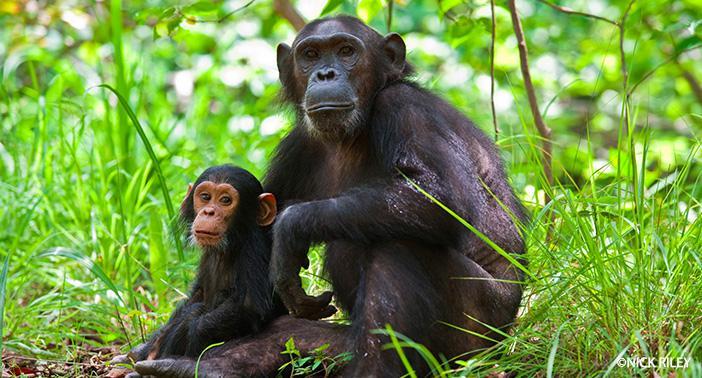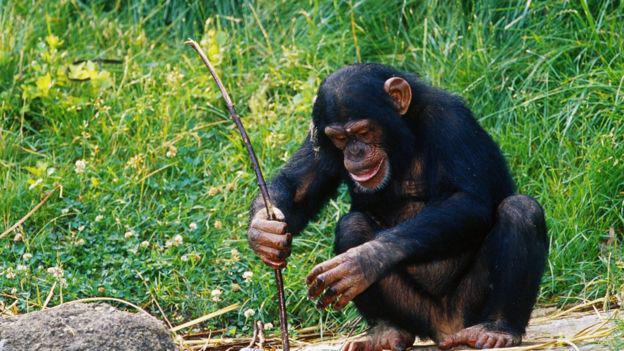The first image is the image on the left, the second image is the image on the right. Given the left and right images, does the statement "There are three apes in total." hold true? Answer yes or no. Yes. 